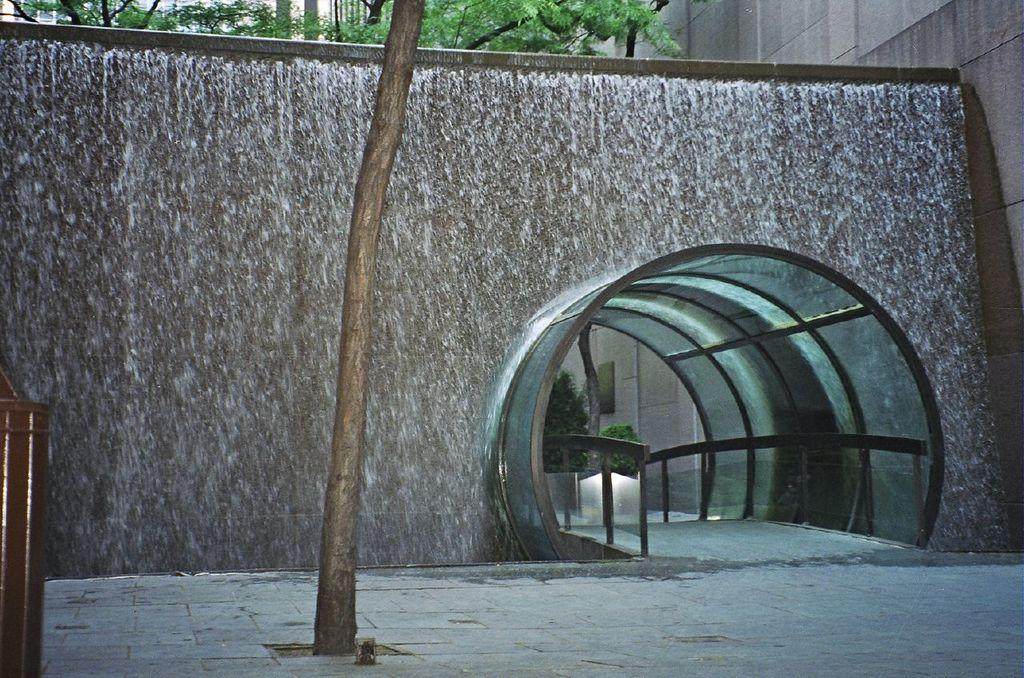What type of structure can be seen in the image? There is a wall in the image. Can you describe any unique features of the wall? There is a tunnel way with glass inside it on the wall. Is there any vegetation visible in the image? Yes, a part of a tree is visible on top of the wall. How does the minister express their hate for ink in the image? There is no minister, hate, or ink present in the image. 